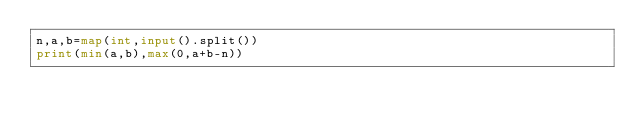Convert code to text. <code><loc_0><loc_0><loc_500><loc_500><_Python_>n,a,b=map(int,input().split())
print(min(a,b),max(0,a+b-n))</code> 